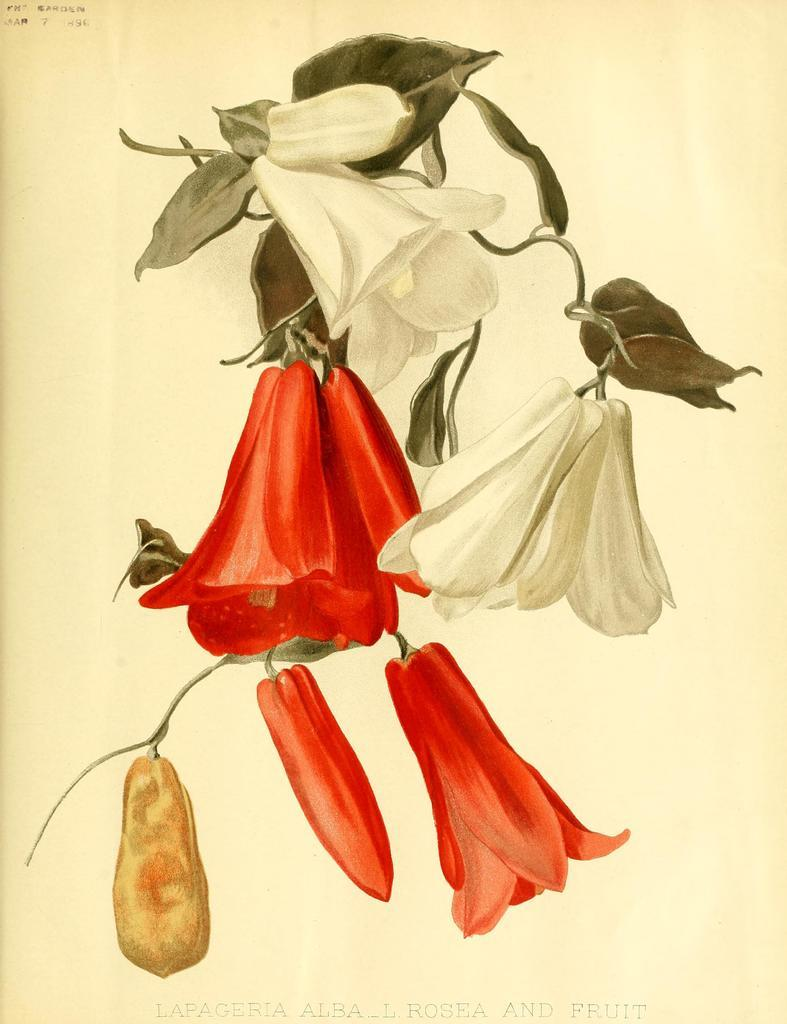What is the main subject of the image? The main subject of the image is a drawing. What can be seen in the drawing? The drawing contains white and red flowers. What type of steel is used to create the yoke in the image? There is no yoke or steel present in the image; it features a drawing with white and red flowers. 